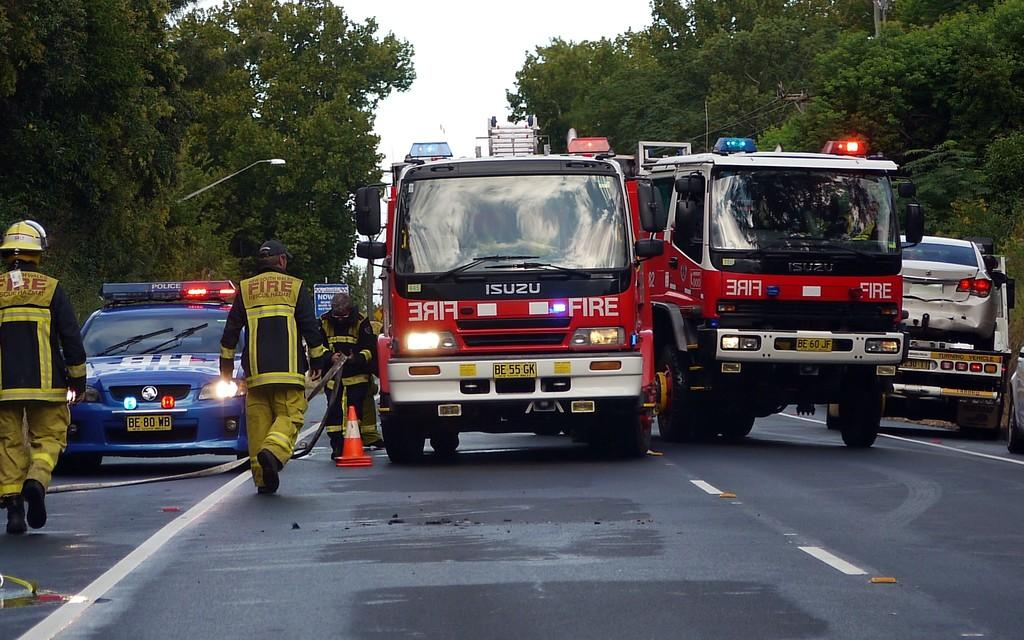What can be seen on the road in the image? There are vehicles on the road in the image. Who is present in the image besides the vehicles? People wearing uniforms are visible in the image. What object can be seen on the road in the image? There is a traffic cone in the image. What is visible in the background of the image? There is a pole, trees, buildings, and the sky visible in the background of the image. What type of structure is being built by the people in the image? There is no structure being built in the image; people wearing uniforms are visible, but no construction activity is taking place. What is the pleasure of the people in the image? The image does not provide information about the emotions or pleasures of the people present. 